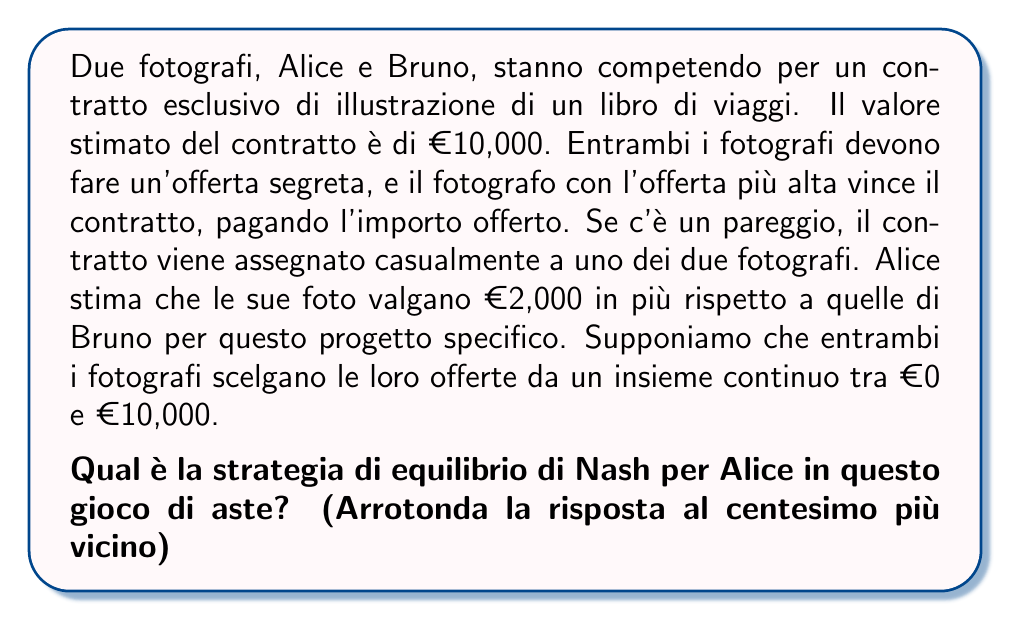Could you help me with this problem? Per risolvere questo problema, utilizziamo il concetto di equilibrio di Nash in un'asta al primo prezzo con valutazioni private.

1) Definiamo le variabili:
   $v_A$: valutazione di Alice
   $v_B$: valutazione di Bruno
   $x$: differenza di valore tra le foto di Alice e Bruno

2) Sappiamo che:
   $v_A = v_B + x$
   $x = 2000$

3) In un'asta al primo prezzo con valutazioni private, la strategia di equilibrio è offrire una frazione della propria valutazione. La frazione ottimale è $(n-1)/n$, dove n è il numero di offerenti.

4) In questo caso, con 2 offerenti, la frazione ottimale è $1/2$.

5) Tuttavia, Alice sa che le sue foto valgono €2,000 in più. Quindi, la sua strategia di equilibrio sarà:

   $$b_A = \frac{1}{2}v_B + x = \frac{1}{2}(v_A - x) + x = \frac{1}{2}v_A + \frac{1}{2}x$$

6) Sostituendo i valori:
   $$b_A = \frac{1}{2}(10000) + \frac{1}{2}(2000) = 5000 + 1000 = 6000$$

Quindi, la strategia di equilibrio di Nash per Alice è offrire €6,000.
Answer: €6,000.00 